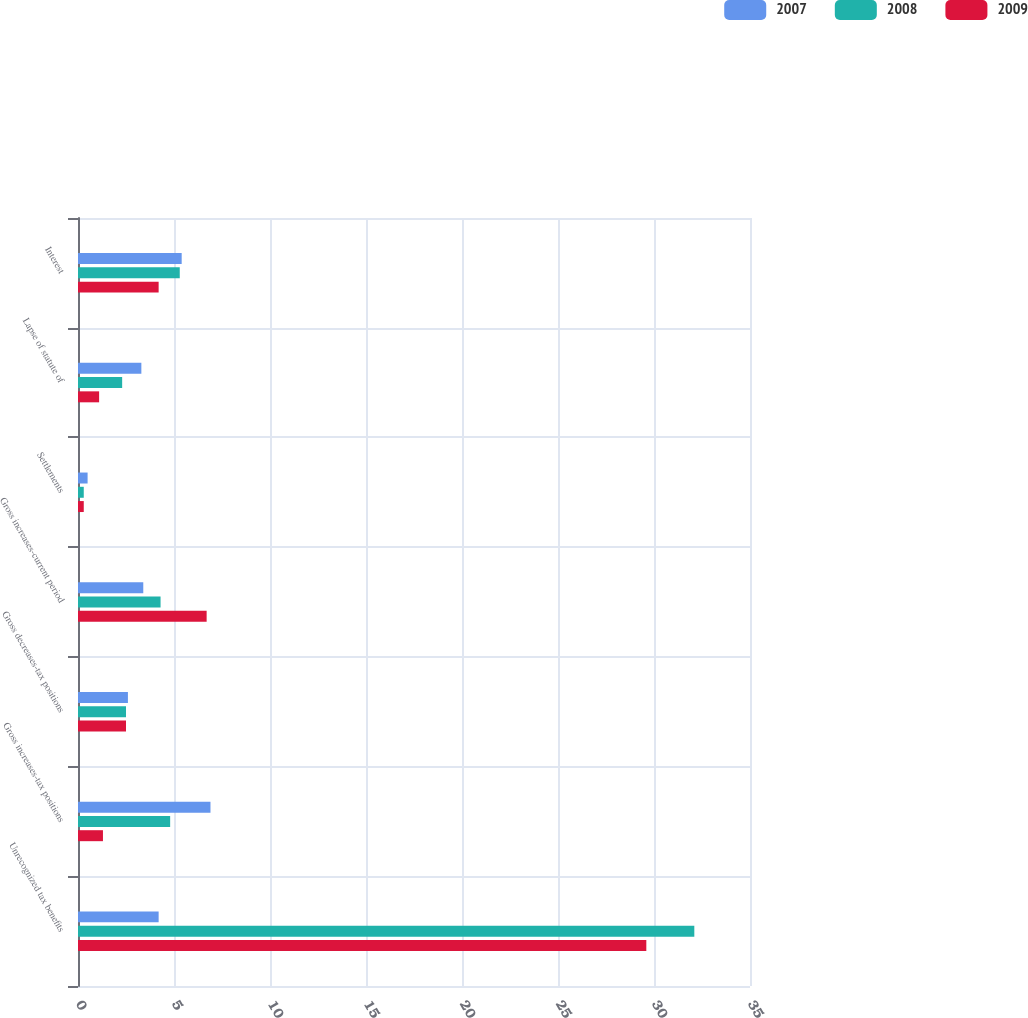<chart> <loc_0><loc_0><loc_500><loc_500><stacked_bar_chart><ecel><fcel>Unrecognized tax benefits<fcel>Gross increases-tax positions<fcel>Gross decreases-tax positions<fcel>Gross increases-current period<fcel>Settlements<fcel>Lapse of statute of<fcel>Interest<nl><fcel>2007<fcel>4.2<fcel>6.9<fcel>2.6<fcel>3.4<fcel>0.5<fcel>3.3<fcel>5.4<nl><fcel>2008<fcel>32.1<fcel>4.8<fcel>2.5<fcel>4.3<fcel>0.3<fcel>2.3<fcel>5.3<nl><fcel>2009<fcel>29.6<fcel>1.3<fcel>2.5<fcel>6.7<fcel>0.3<fcel>1.1<fcel>4.2<nl></chart> 